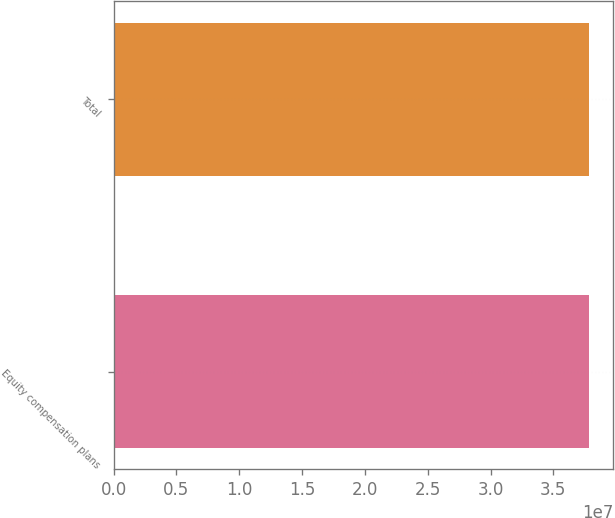Convert chart. <chart><loc_0><loc_0><loc_500><loc_500><bar_chart><fcel>Equity compensation plans<fcel>Total<nl><fcel>3.78694e+07<fcel>3.78694e+07<nl></chart> 